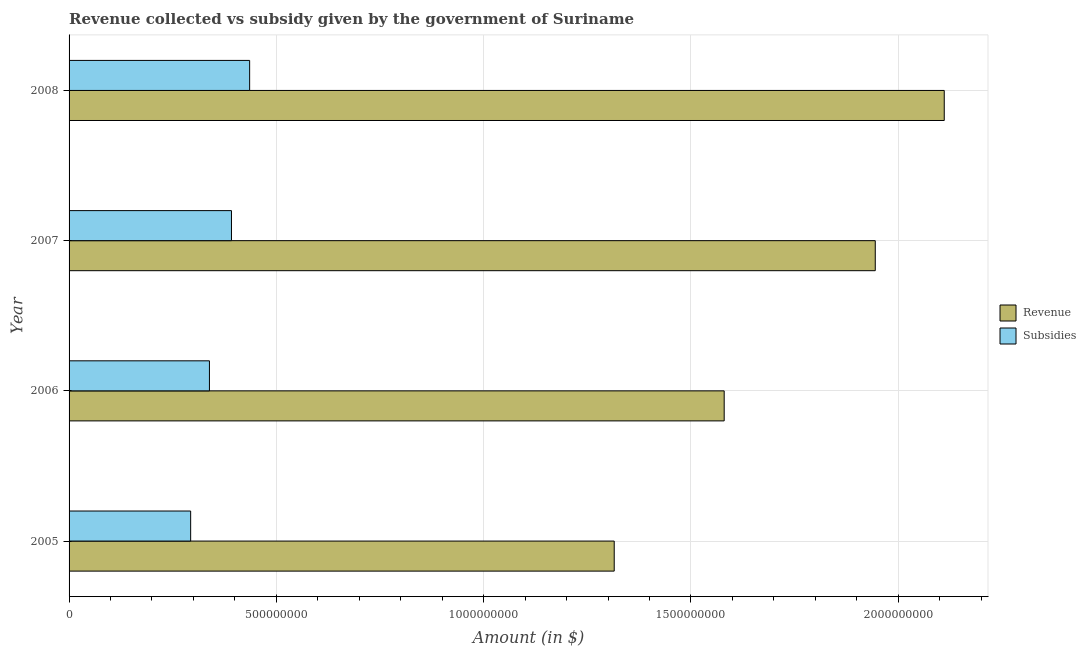How many different coloured bars are there?
Keep it short and to the point. 2. How many bars are there on the 1st tick from the top?
Your response must be concise. 2. In how many cases, is the number of bars for a given year not equal to the number of legend labels?
Offer a terse response. 0. What is the amount of revenue collected in 2008?
Offer a terse response. 2.11e+09. Across all years, what is the maximum amount of subsidies given?
Provide a short and direct response. 4.36e+08. Across all years, what is the minimum amount of revenue collected?
Your answer should be very brief. 1.32e+09. In which year was the amount of revenue collected maximum?
Offer a very short reply. 2008. In which year was the amount of revenue collected minimum?
Keep it short and to the point. 2005. What is the total amount of subsidies given in the graph?
Your answer should be compact. 1.46e+09. What is the difference between the amount of subsidies given in 2005 and that in 2006?
Your answer should be very brief. -4.53e+07. What is the difference between the amount of subsidies given in 2008 and the amount of revenue collected in 2005?
Make the answer very short. -8.79e+08. What is the average amount of revenue collected per year?
Offer a terse response. 1.74e+09. In the year 2005, what is the difference between the amount of subsidies given and amount of revenue collected?
Give a very brief answer. -1.02e+09. In how many years, is the amount of revenue collected greater than 1200000000 $?
Your answer should be compact. 4. What is the ratio of the amount of revenue collected in 2005 to that in 2008?
Give a very brief answer. 0.62. Is the difference between the amount of revenue collected in 2006 and 2007 greater than the difference between the amount of subsidies given in 2006 and 2007?
Your answer should be very brief. No. What is the difference between the highest and the second highest amount of subsidies given?
Offer a very short reply. 4.38e+07. What is the difference between the highest and the lowest amount of revenue collected?
Give a very brief answer. 7.96e+08. Is the sum of the amount of revenue collected in 2005 and 2007 greater than the maximum amount of subsidies given across all years?
Ensure brevity in your answer.  Yes. What does the 2nd bar from the top in 2006 represents?
Provide a short and direct response. Revenue. What does the 1st bar from the bottom in 2006 represents?
Your response must be concise. Revenue. How many bars are there?
Make the answer very short. 8. Are all the bars in the graph horizontal?
Your answer should be compact. Yes. Are the values on the major ticks of X-axis written in scientific E-notation?
Your response must be concise. No. Does the graph contain any zero values?
Keep it short and to the point. No. Does the graph contain grids?
Make the answer very short. Yes. How many legend labels are there?
Your answer should be compact. 2. What is the title of the graph?
Your response must be concise. Revenue collected vs subsidy given by the government of Suriname. Does "Secondary education" appear as one of the legend labels in the graph?
Provide a short and direct response. No. What is the label or title of the X-axis?
Provide a short and direct response. Amount (in $). What is the Amount (in $) of Revenue in 2005?
Ensure brevity in your answer.  1.32e+09. What is the Amount (in $) in Subsidies in 2005?
Offer a very short reply. 2.93e+08. What is the Amount (in $) of Revenue in 2006?
Keep it short and to the point. 1.58e+09. What is the Amount (in $) in Subsidies in 2006?
Offer a very short reply. 3.39e+08. What is the Amount (in $) in Revenue in 2007?
Ensure brevity in your answer.  1.94e+09. What is the Amount (in $) of Subsidies in 2007?
Your answer should be compact. 3.92e+08. What is the Amount (in $) in Revenue in 2008?
Offer a very short reply. 2.11e+09. What is the Amount (in $) of Subsidies in 2008?
Ensure brevity in your answer.  4.36e+08. Across all years, what is the maximum Amount (in $) of Revenue?
Your answer should be very brief. 2.11e+09. Across all years, what is the maximum Amount (in $) of Subsidies?
Your response must be concise. 4.36e+08. Across all years, what is the minimum Amount (in $) of Revenue?
Your answer should be compact. 1.32e+09. Across all years, what is the minimum Amount (in $) of Subsidies?
Offer a very short reply. 2.93e+08. What is the total Amount (in $) in Revenue in the graph?
Ensure brevity in your answer.  6.95e+09. What is the total Amount (in $) of Subsidies in the graph?
Offer a very short reply. 1.46e+09. What is the difference between the Amount (in $) in Revenue in 2005 and that in 2006?
Provide a short and direct response. -2.65e+08. What is the difference between the Amount (in $) in Subsidies in 2005 and that in 2006?
Provide a succinct answer. -4.53e+07. What is the difference between the Amount (in $) of Revenue in 2005 and that in 2007?
Provide a short and direct response. -6.30e+08. What is the difference between the Amount (in $) in Subsidies in 2005 and that in 2007?
Provide a short and direct response. -9.84e+07. What is the difference between the Amount (in $) of Revenue in 2005 and that in 2008?
Offer a very short reply. -7.96e+08. What is the difference between the Amount (in $) of Subsidies in 2005 and that in 2008?
Give a very brief answer. -1.42e+08. What is the difference between the Amount (in $) in Revenue in 2006 and that in 2007?
Make the answer very short. -3.64e+08. What is the difference between the Amount (in $) in Subsidies in 2006 and that in 2007?
Your response must be concise. -5.32e+07. What is the difference between the Amount (in $) in Revenue in 2006 and that in 2008?
Your answer should be very brief. -5.31e+08. What is the difference between the Amount (in $) of Subsidies in 2006 and that in 2008?
Keep it short and to the point. -9.70e+07. What is the difference between the Amount (in $) of Revenue in 2007 and that in 2008?
Provide a succinct answer. -1.66e+08. What is the difference between the Amount (in $) in Subsidies in 2007 and that in 2008?
Offer a very short reply. -4.38e+07. What is the difference between the Amount (in $) of Revenue in 2005 and the Amount (in $) of Subsidies in 2006?
Offer a very short reply. 9.76e+08. What is the difference between the Amount (in $) of Revenue in 2005 and the Amount (in $) of Subsidies in 2007?
Your answer should be compact. 9.23e+08. What is the difference between the Amount (in $) in Revenue in 2005 and the Amount (in $) in Subsidies in 2008?
Provide a short and direct response. 8.79e+08. What is the difference between the Amount (in $) in Revenue in 2006 and the Amount (in $) in Subsidies in 2007?
Your answer should be compact. 1.19e+09. What is the difference between the Amount (in $) of Revenue in 2006 and the Amount (in $) of Subsidies in 2008?
Provide a succinct answer. 1.14e+09. What is the difference between the Amount (in $) in Revenue in 2007 and the Amount (in $) in Subsidies in 2008?
Ensure brevity in your answer.  1.51e+09. What is the average Amount (in $) in Revenue per year?
Your answer should be compact. 1.74e+09. What is the average Amount (in $) in Subsidies per year?
Offer a very short reply. 3.65e+08. In the year 2005, what is the difference between the Amount (in $) in Revenue and Amount (in $) in Subsidies?
Your answer should be very brief. 1.02e+09. In the year 2006, what is the difference between the Amount (in $) of Revenue and Amount (in $) of Subsidies?
Provide a short and direct response. 1.24e+09. In the year 2007, what is the difference between the Amount (in $) of Revenue and Amount (in $) of Subsidies?
Your answer should be very brief. 1.55e+09. In the year 2008, what is the difference between the Amount (in $) of Revenue and Amount (in $) of Subsidies?
Provide a succinct answer. 1.68e+09. What is the ratio of the Amount (in $) in Revenue in 2005 to that in 2006?
Offer a very short reply. 0.83. What is the ratio of the Amount (in $) in Subsidies in 2005 to that in 2006?
Give a very brief answer. 0.87. What is the ratio of the Amount (in $) of Revenue in 2005 to that in 2007?
Offer a terse response. 0.68. What is the ratio of the Amount (in $) of Subsidies in 2005 to that in 2007?
Make the answer very short. 0.75. What is the ratio of the Amount (in $) in Revenue in 2005 to that in 2008?
Ensure brevity in your answer.  0.62. What is the ratio of the Amount (in $) in Subsidies in 2005 to that in 2008?
Provide a succinct answer. 0.67. What is the ratio of the Amount (in $) in Revenue in 2006 to that in 2007?
Your response must be concise. 0.81. What is the ratio of the Amount (in $) of Subsidies in 2006 to that in 2007?
Your answer should be compact. 0.86. What is the ratio of the Amount (in $) in Revenue in 2006 to that in 2008?
Make the answer very short. 0.75. What is the ratio of the Amount (in $) of Subsidies in 2006 to that in 2008?
Ensure brevity in your answer.  0.78. What is the ratio of the Amount (in $) of Revenue in 2007 to that in 2008?
Keep it short and to the point. 0.92. What is the ratio of the Amount (in $) of Subsidies in 2007 to that in 2008?
Your response must be concise. 0.9. What is the difference between the highest and the second highest Amount (in $) of Revenue?
Keep it short and to the point. 1.66e+08. What is the difference between the highest and the second highest Amount (in $) in Subsidies?
Your answer should be very brief. 4.38e+07. What is the difference between the highest and the lowest Amount (in $) of Revenue?
Offer a very short reply. 7.96e+08. What is the difference between the highest and the lowest Amount (in $) of Subsidies?
Provide a short and direct response. 1.42e+08. 